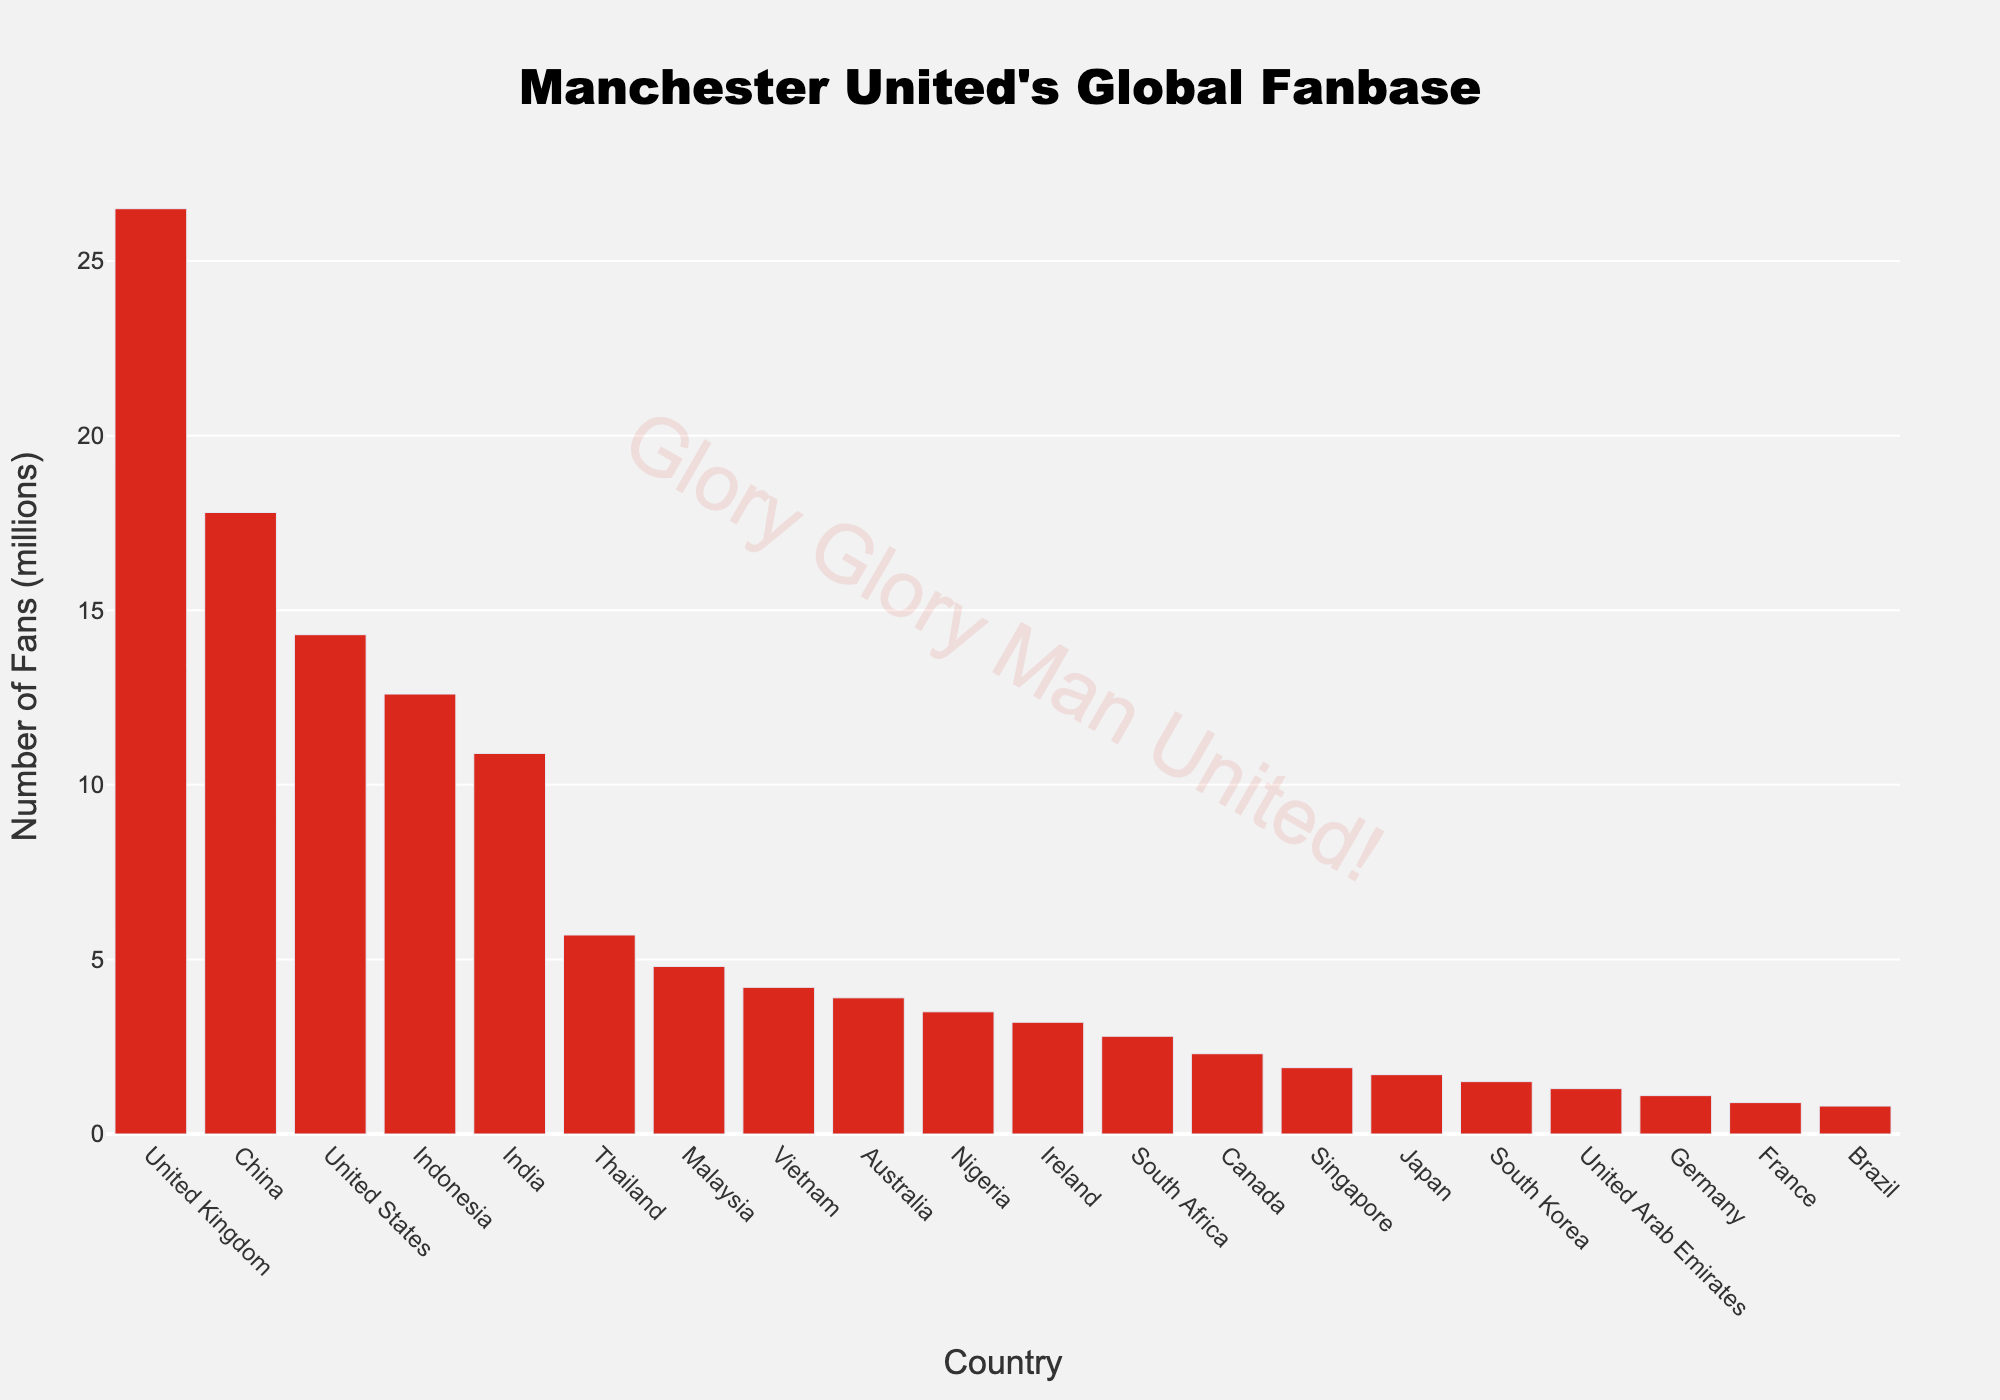Which country has the highest number of Manchester United fans? The data shows bar heights representing fan counts for each country, and the United Kingdom has the tallest bar.
Answer: United Kingdom What is the total number of Manchester United fans in Ireland, Australia, and Canada combined? Adding the fan counts: Ireland (3.2 million) + Australia (3.9 million) + Canada (2.3 million) = 3.2 + 3.9 + 2.3 = 9.4 million
Answer: 9.4 million How many more fans does Manchester United have in China compared to the United States? China's fan count is 17.8 million, and the United States' fan count is 14.3 million. The difference is 17.8 - 14.3 = 3.5 million
Answer: 3.5 million Which countries have fewer than 3 million Manchester United fans? Observing the bar heights, the countries with fewer than 3 million fans are South Africa, Canada, Singapore, Japan, South Korea, United Arab Emirates, Germany, France, and Brazil.
Answer: South Africa, Canada, Singapore, Japan, South Korea, United Arab Emirates, Germany, France, Brazil How many fans do Manchester United have in Asia if we sum the fan counts from China, Indonesia, India, Thailand, Malaysia, Vietnam, Japan, and South Korea? Adding the fan counts: China (17.8 million) + Indonesia (12.6 million) + India (10.9 million) + Thailand (5.7 million) + Malaysia (4.8 million) + Vietnam (4.2 million) + Japan (1.7 million) + South Korea (1.5 million) = 59.2 million
Answer: 59.2 million Between Nigeria and the United Arab Emirates, which country has fewer Manchester United fans and by how much? Nigeria has 3.5 million fans, and the United Arab Emirates has 1.3 million. The difference is 3.5 - 1.3 = 2.2 million.
Answer: United Arab Emirates, 2.2 million What is the average number of fans across the ten countries with the most fans? The top 10 countries by fan count are United Kingdom (26.5 million), China (17.8 million), United States (14.3 million), Indonesia (12.6 million), India (10.9 million), Thailand (5.7 million), Malaysia (4.8 million), Vietnam (4.2 million), Australia (3.9 million), and Nigeria (3.5 million). Sum these: 26.5 + 17.8 + 14.3 + 12.6 + 10.9 + 5.7 + 4.8 + 4.2 + 3.9 + 3.5 = 104.2 million. Divide by 10 = 104.2 / 10 = 10.42 million
Answer: 10.42 million Which country has the fewest Manchester United fans? The shortest bar represents Brazil, with the smallest fan count.
Answer: Brazil Compare the fan count in Ireland to that in Vietnam. Which country has more fans and what's the percentage difference? Ireland has 3.2 million fans, and Vietnam has 4.2 million fans. Vietnam has more fans. The percentage difference is calculated as (4.2 - 3.2) / 3.2 * 100% = 1 / 3.2 * 100% ≈ 31.25%
Answer: Vietnam, approximately 31.25% What is the combined number of Manchester United fans in all European countries listed? The European countries listed are United Kingdom (26.5 million), Ireland (3.2 million), Germany (1.1 million), and France (0.9 million). Sum these: 26.5 + 3.2 + 1.1 + 0.9 = 31.7 million
Answer: 31.7 million 